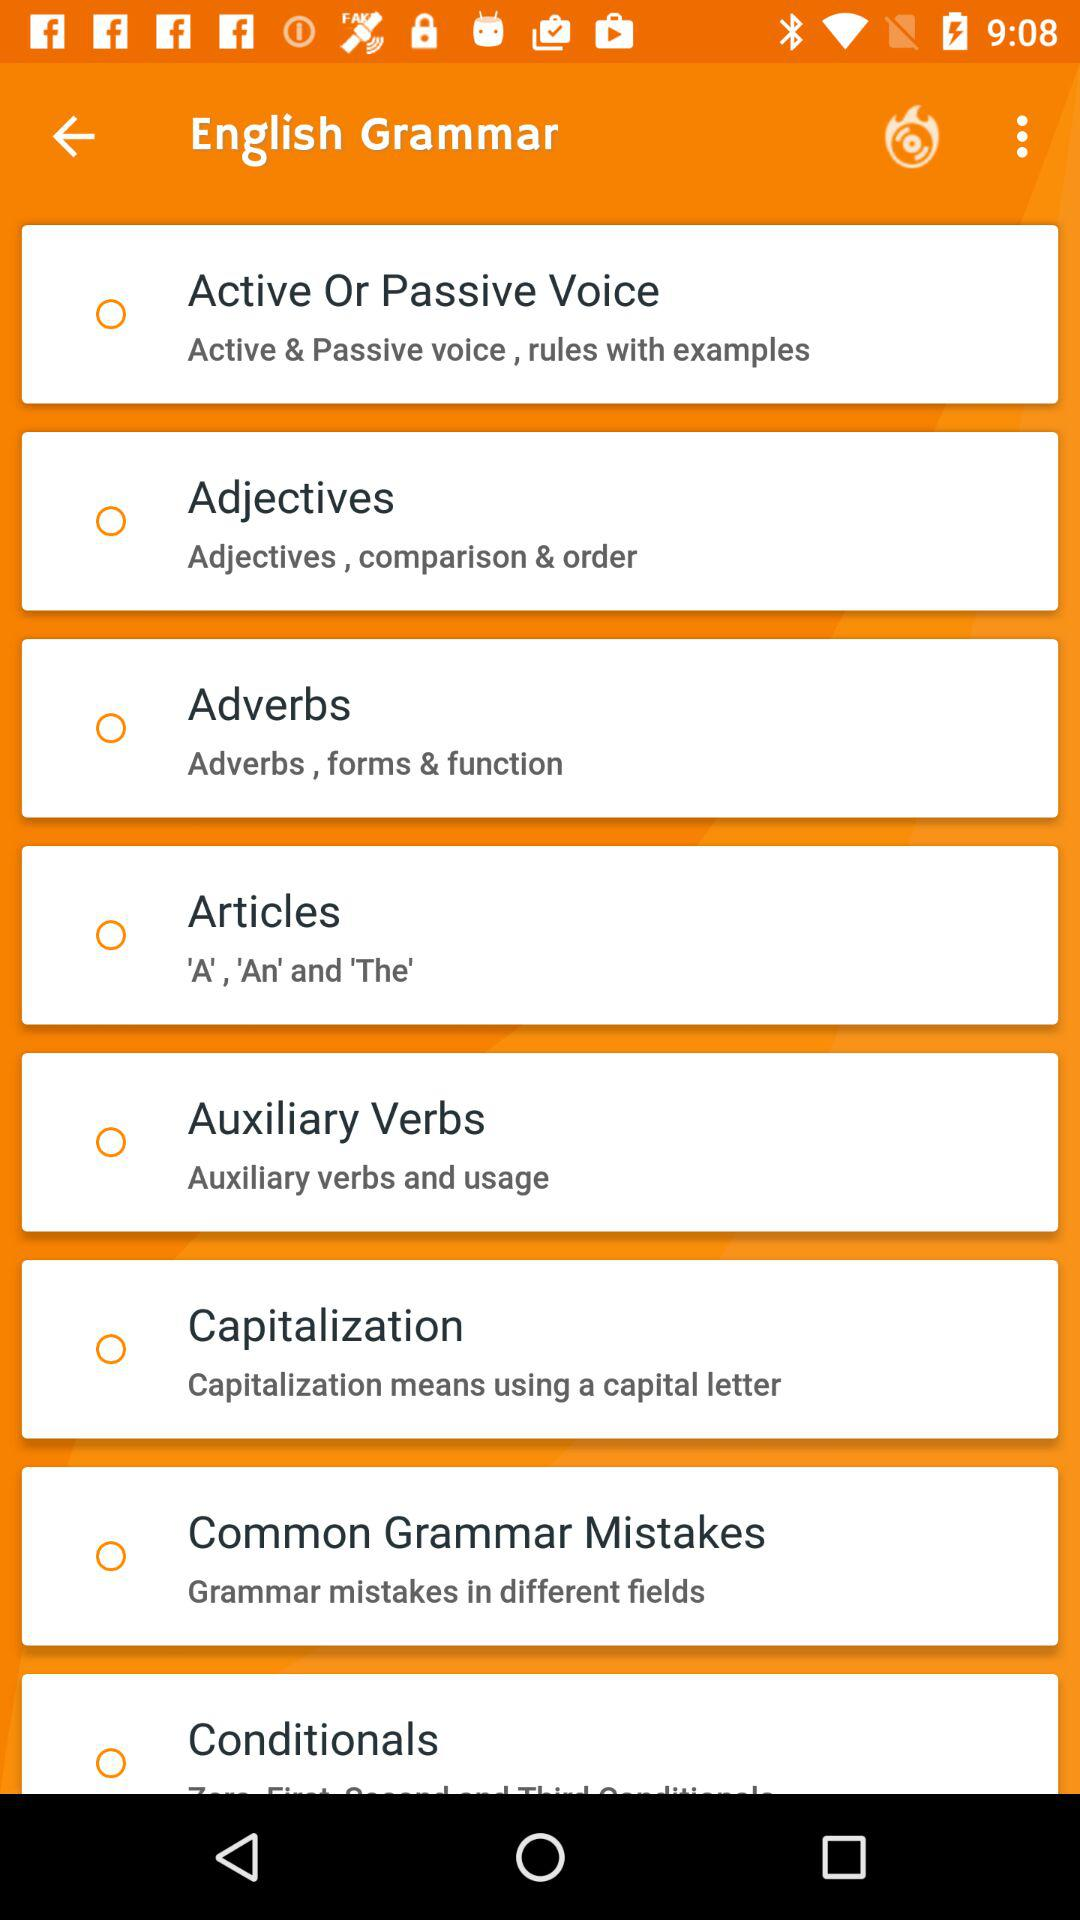What content is available? The available contents are "Active Or Passive Voice", "Adjectives", "Adverbs", "Articles", "Auxiliary Verbs", "Capitalization", "Common Grammar Mistakes" and "Conditionals". 